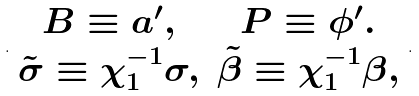Convert formula to latex. <formula><loc_0><loc_0><loc_500><loc_500>. \begin{array} { c c } B \equiv a ^ { \prime } , & P \equiv \phi ^ { \prime } . \\ \tilde { \sigma } \equiv \chi _ { 1 } ^ { - 1 } \sigma , & \tilde { \beta } \equiv \chi _ { 1 } ^ { - 1 } \beta , \end{array} .</formula> 